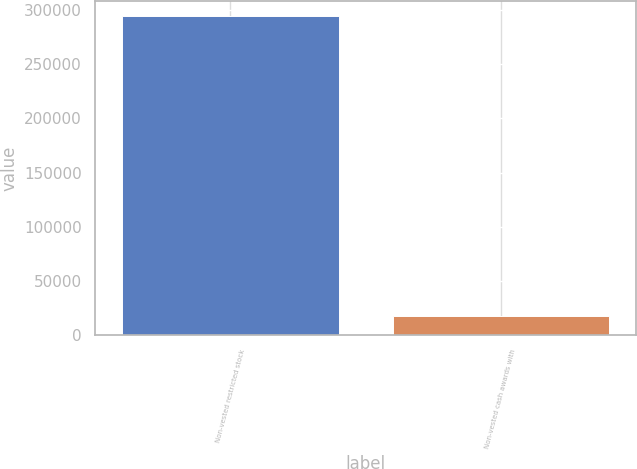<chart> <loc_0><loc_0><loc_500><loc_500><bar_chart><fcel>Non-vested restricted stock<fcel>Non-vested cash awards with<nl><fcel>293800<fcel>17650<nl></chart> 